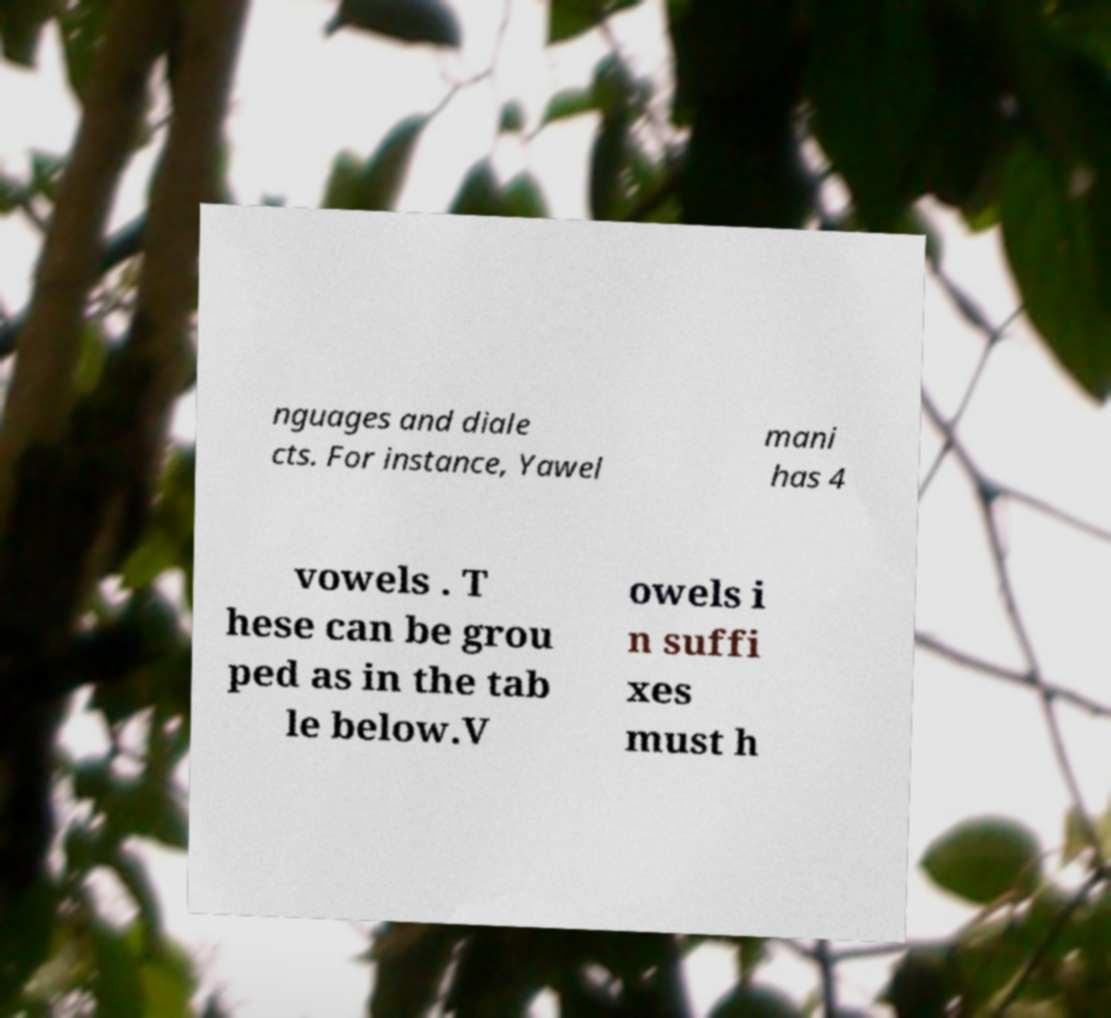Please identify and transcribe the text found in this image. nguages and diale cts. For instance, Yawel mani has 4 vowels . T hese can be grou ped as in the tab le below.V owels i n suffi xes must h 